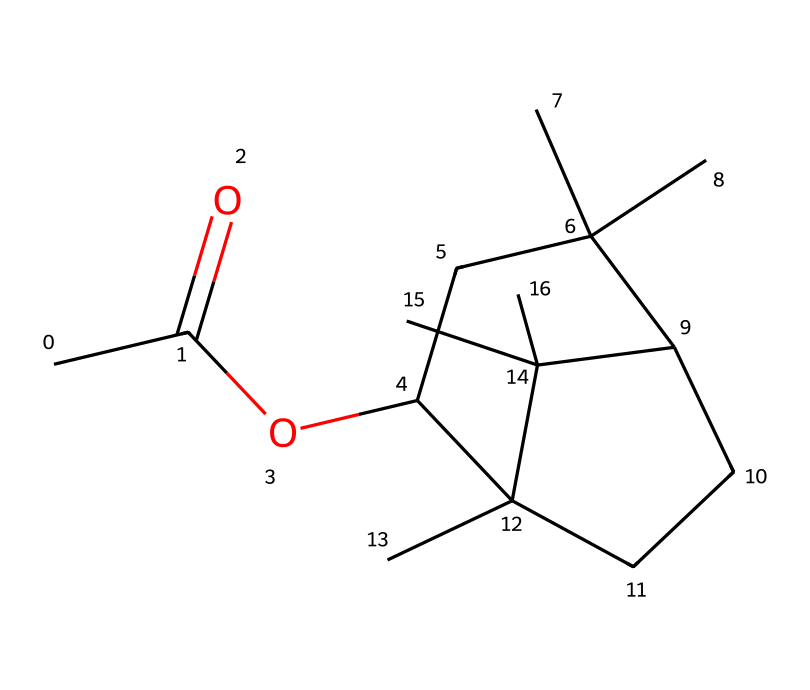How many carbon atoms are in the chemical? By counting the carbon atoms present in the SMILES notation, we observe that there are a total of 15 carbon atoms indicated.
Answer: 15 What type of functional group is present in this chemical? Reviewing the structure, we see the presence of an ester functional group (CC(=O)O) indicated by the carbonyl (C=O) and the oxygen (O) that follows.
Answer: ester What is the degree of saturation of the compound? The degree of saturation can be identified through the structure's rings and double bonds. Since there are multiple rings and no double bonds outside of the carbonyl one, the degree of saturation is high; this compound is likely fully saturated.
Answer: saturated What kind of scent does this chemical likely produce? Considering the molecular structure and its classification as a sakura fragrance, we can deduce that it produces a floral aroma associated with cherry blossoms.
Answer: floral How many rings are present in the structure? Inspecting the structure, it contains two distinct cyclic components that form the overall compound. Thus, there are 2 rings present.
Answer: 2 What type of compound is this in terms of its application in flavors and fragrances? This compound is specifically used as a fragrance component, particularly classified within the category of esters due to its structure and usage in perfumery.
Answer: fragrance 